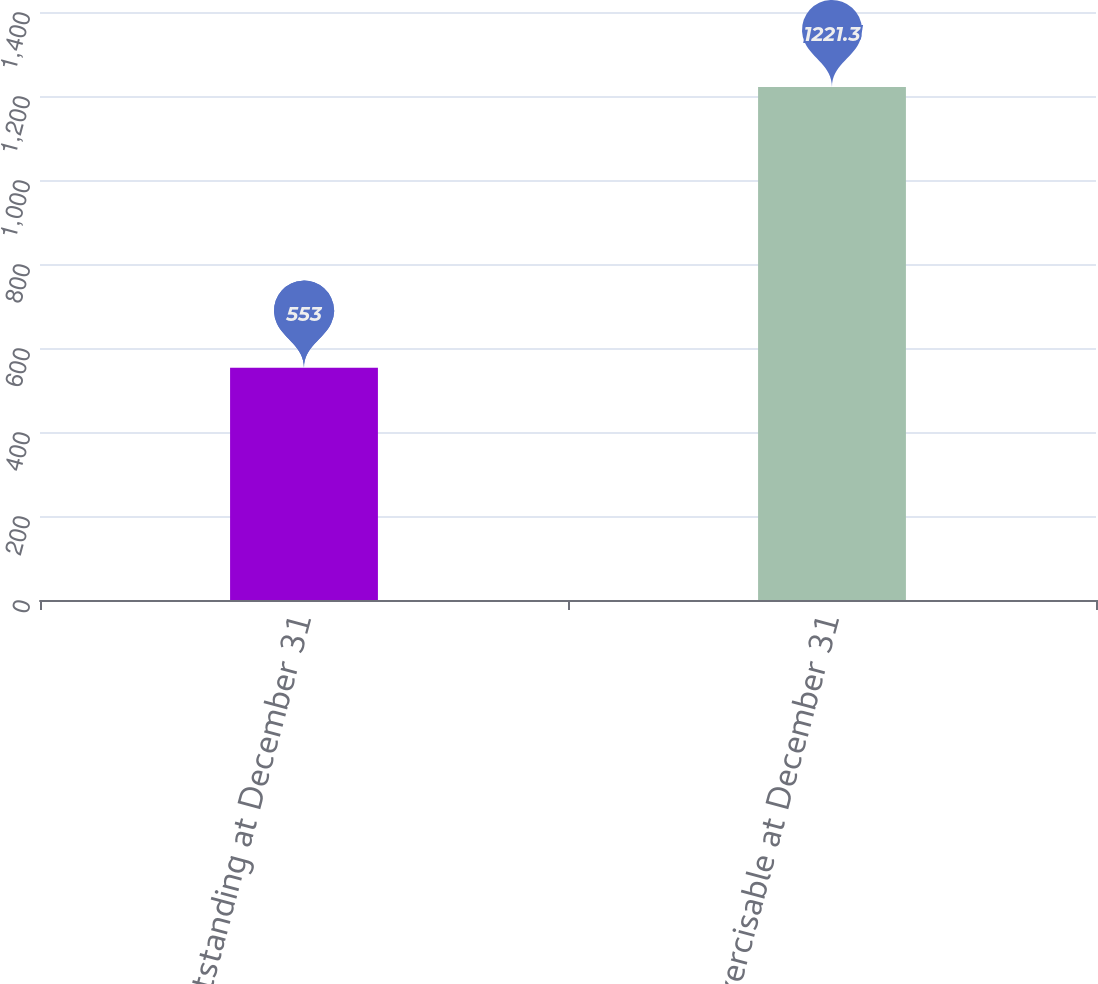<chart> <loc_0><loc_0><loc_500><loc_500><bar_chart><fcel>Outstanding at December 31<fcel>Exercisable at December 31<nl><fcel>553<fcel>1221.3<nl></chart> 